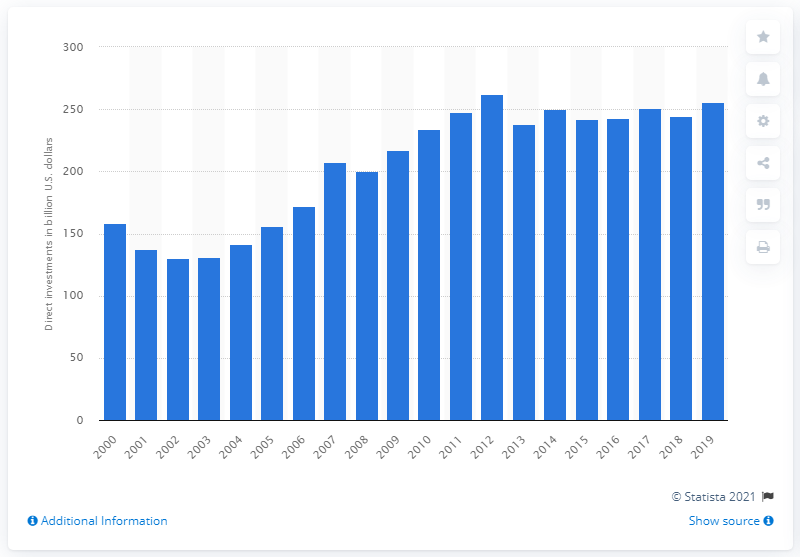List a handful of essential elements in this visual. In 2019, a total of 256.07 dollars were invested in Central and South America. 